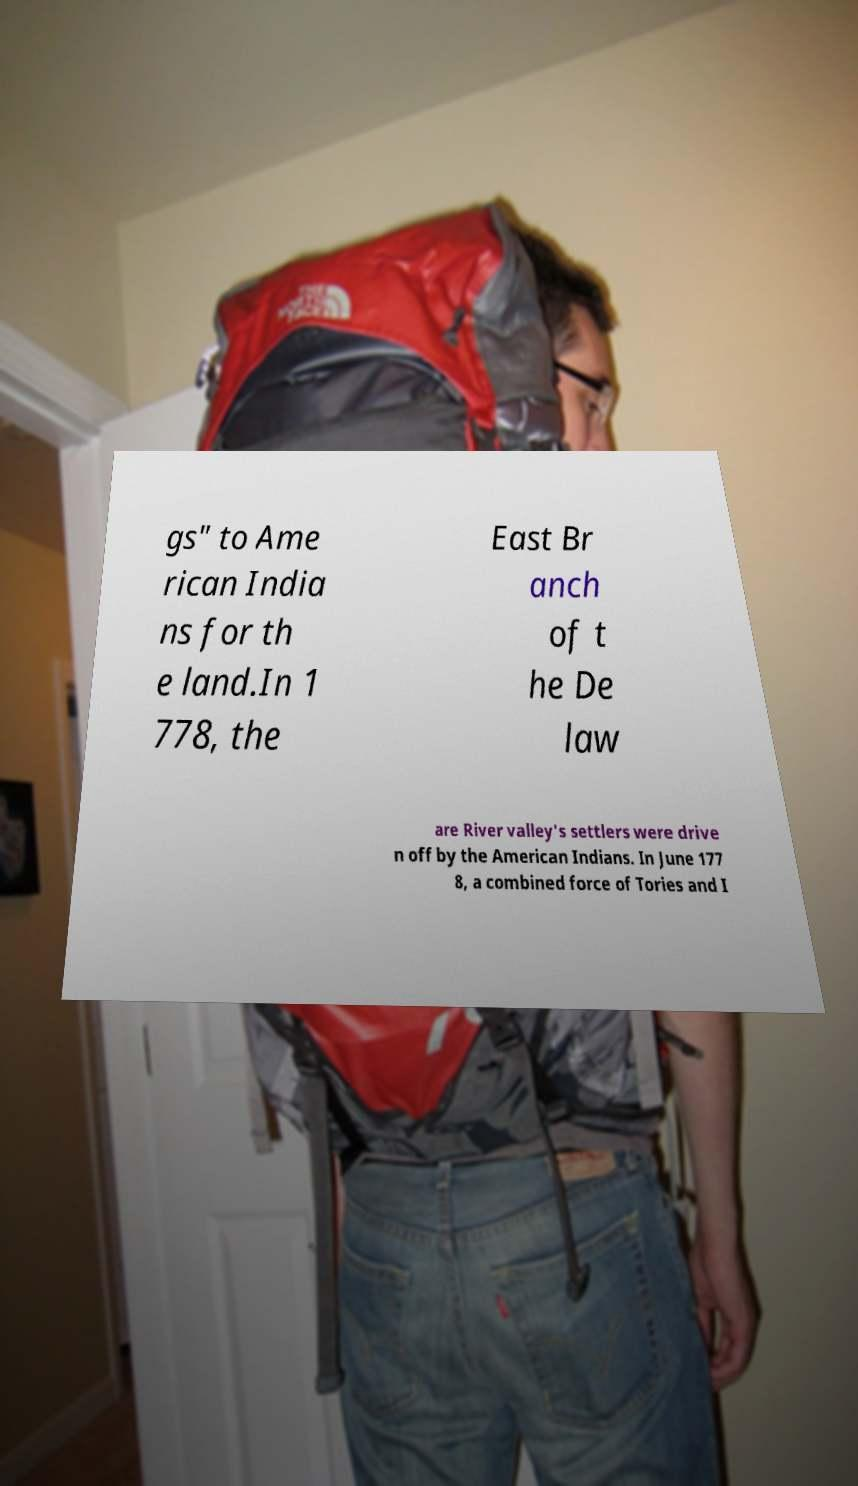What messages or text are displayed in this image? I need them in a readable, typed format. gs" to Ame rican India ns for th e land.In 1 778, the East Br anch of t he De law are River valley's settlers were drive n off by the American Indians. In June 177 8, a combined force of Tories and I 